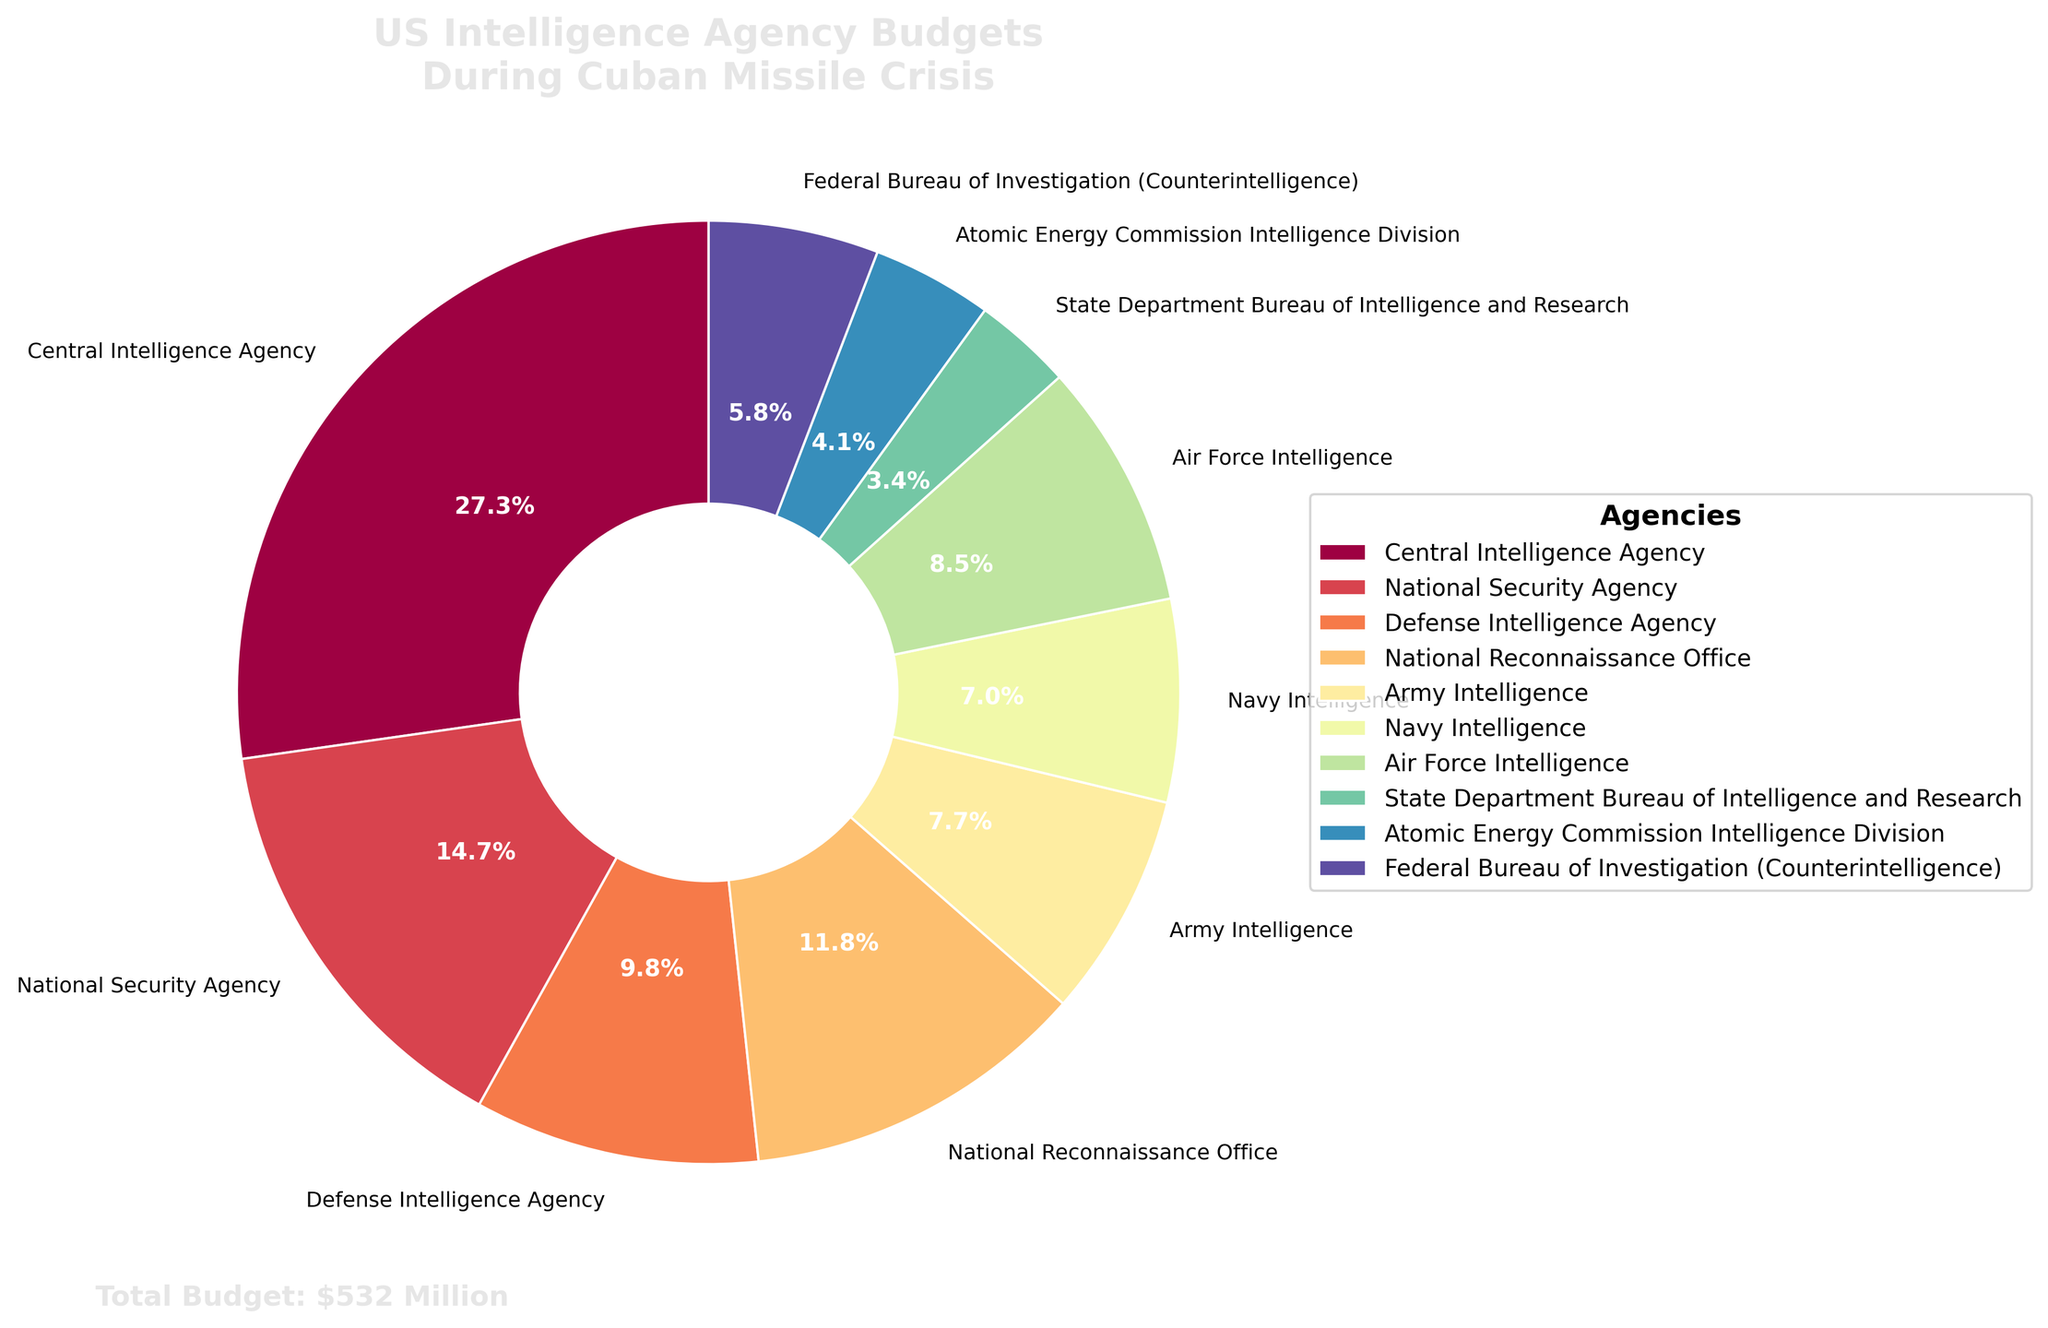What percentage of the total budget does the CIA have? From the figure, identify the wedge labeled "Central Intelligence Agency" and note the associated percentage displayed inside the wedge.
Answer: 27.3% How much larger is the CIA’s budget compared to the State Department Bureau of Intelligence and Research? The wedge for the CIA shows a budget of $145 million, while the State Department Bureau of Intelligence and Research wedge shows $18 million. Subtract the latter from the former: 145 - 18 = 127 million USD.
Answer: 127 million USD Which agency has the second-largest budget? From the pie chart, identify the wedges and their percentages or values. The National Security Agency (NSA) has the second highest budget shown with $78 million.
Answer: National Security Agency How do the budgets of the Air Force Intelligence and the Army Intelligence compare? The pie chart shows Air Force Intelligence has $45 million and Army Intelligence has $41 million. Compare these values: 45 million > 41 million.
Answer: Air Force Intelligence has a larger budget Which two agencies combined make up approximately the same budget as the CIA? The CIA budget is $145 million. By examining the pie chart, observe that $78 million (NSA) + $63 million (NRO) amounts to $141 million, which is close to the CIA budget.
Answer: NSA and NRO What is the combined budget for the Defense Intelligence Agency and Federal Bureau of Investigation? From the chart, find the budgets for the DIA (52 million) and FBI (31 million). Sum these amounts: 52 + 31 = 83 million USD.
Answer: 83 million USD Which agency has the smallest budget and what is its percentage of the total budget? Locate the smallest wedge on the pie chart, which corresponds to the State Department Bureau of Intelligence and Research with a budget of $18 million. The percentage can be identified directly from the wedge: 3.4%.
Answer: State Department Bureau of Intelligence and Research, 3.4% How many agencies have a budget of over $50 million? Count the wedges each representing over $50 million. These are CIA ($145M), NSA ($78M), DIA ($52M), and NRO ($63M), totaling 4 agencies.
Answer: 4 agencies What is the total budget for all intelligence agencies? The chart indicates a total budget annotation as "$532 Million."
Answer: 532 million USD 